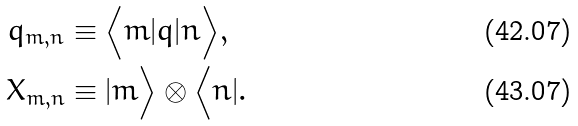<formula> <loc_0><loc_0><loc_500><loc_500>q _ { m , n } & \equiv \Big < m | q | n \Big > , \\ X _ { m , n } & \equiv | m \Big > \otimes \Big < n | .</formula> 